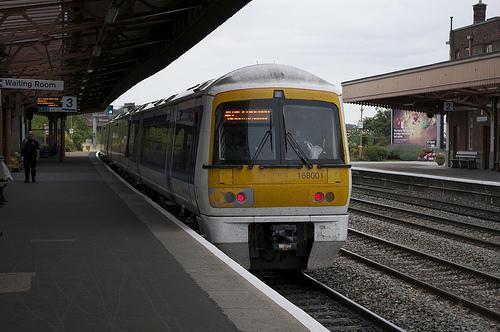How many people are on the platform?
Give a very brief answer. 1. 